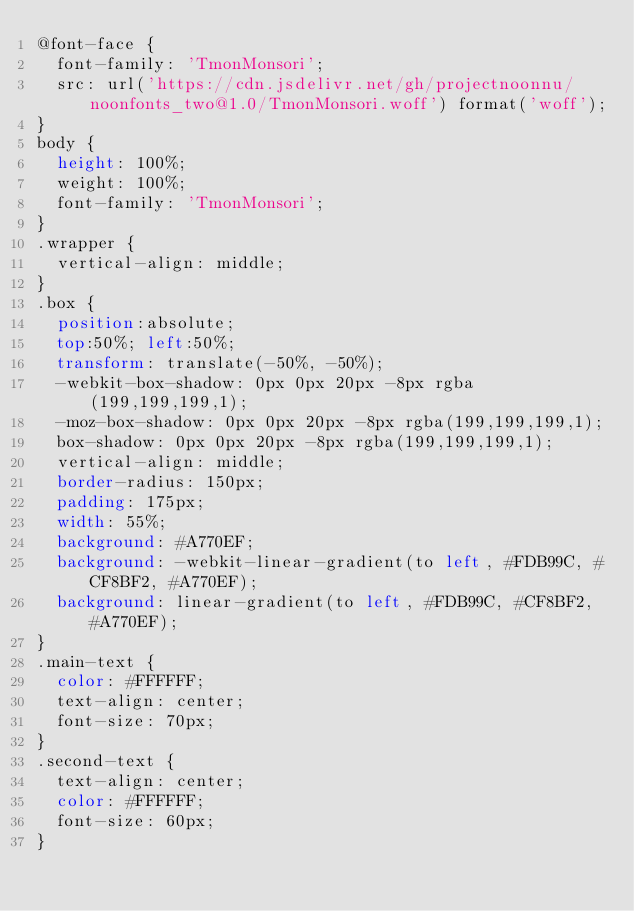Convert code to text. <code><loc_0><loc_0><loc_500><loc_500><_CSS_>@font-face {
  font-family: 'TmonMonsori';
  src: url('https://cdn.jsdelivr.net/gh/projectnoonnu/noonfonts_two@1.0/TmonMonsori.woff') format('woff');
}
body {
  height: 100%;
  weight: 100%;
  font-family: 'TmonMonsori';
}
.wrapper {
  vertical-align: middle;
}
.box {
  position:absolute;
  top:50%; left:50%;
  transform: translate(-50%, -50%);
  -webkit-box-shadow: 0px 0px 20px -8px rgba(199,199,199,1);
  -moz-box-shadow: 0px 0px 20px -8px rgba(199,199,199,1);
  box-shadow: 0px 0px 20px -8px rgba(199,199,199,1);
  vertical-align: middle;
  border-radius: 150px;
  padding: 175px;
  width: 55%;
  background: #A770EF;
  background: -webkit-linear-gradient(to left, #FDB99C, #CF8BF2, #A770EF);
  background: linear-gradient(to left, #FDB99C, #CF8BF2, #A770EF);
}
.main-text {
  color: #FFFFFF;
  text-align: center;
  font-size: 70px;
}
.second-text {
  text-align: center;
  color: #FFFFFF;
  font-size: 60px;
}
</code> 